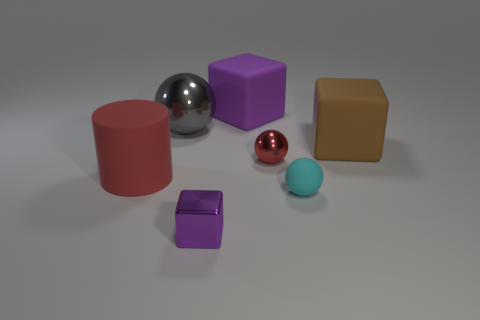How does the lighting in the image affect the appearance of the objects? The lighting creates a soft shadow on the right side of each object, suggesting a light source to the left. This affects their appearance by giving them a sense of volume and depth. The reflective objects catch the light to a greater extent, which enhances their shine and highlights their shapes. 